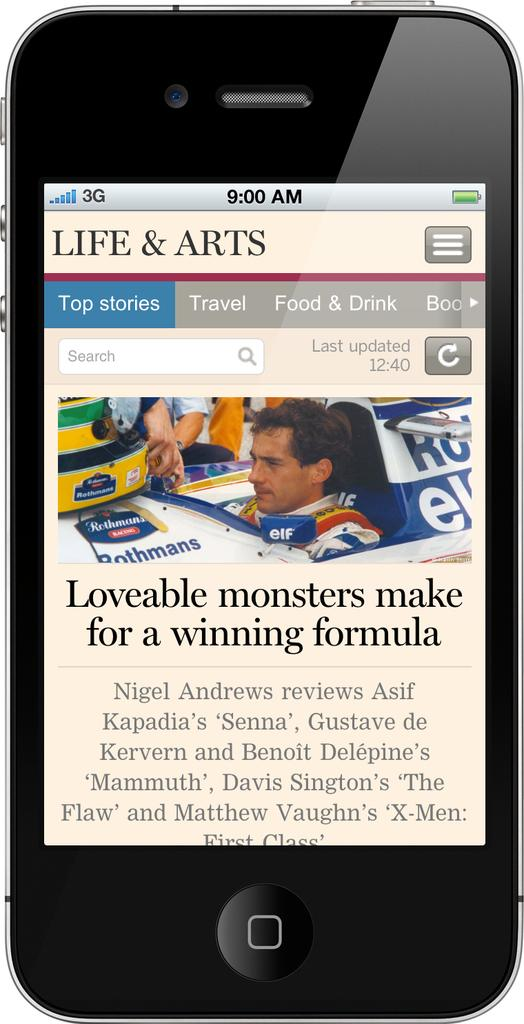What electronic device is visible in the image? There is a mobile phone in the image. What is displayed on the mobile phone's screen? The mobile phone's screen displays news. Can you describe the image on the screen? There is a person's image on the screen. What else can be seen on the screen besides the image? There is text present on the screen. What type of leather can be seen on the store's slope in the image? There is no leather, store, or slope present in the image. 